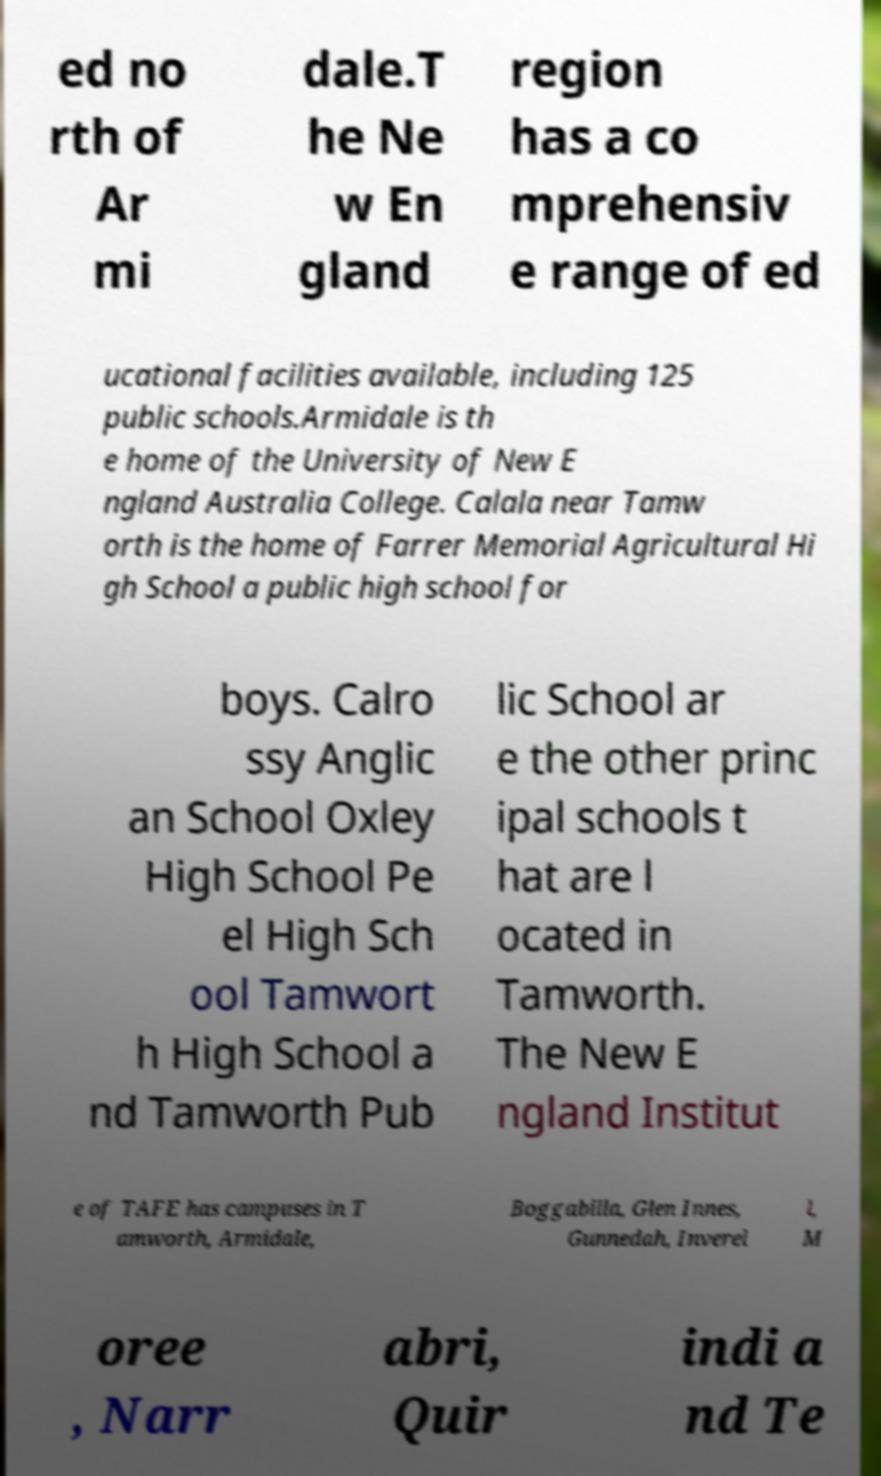For documentation purposes, I need the text within this image transcribed. Could you provide that? ed no rth of Ar mi dale.T he Ne w En gland region has a co mprehensiv e range of ed ucational facilities available, including 125 public schools.Armidale is th e home of the University of New E ngland Australia College. Calala near Tamw orth is the home of Farrer Memorial Agricultural Hi gh School a public high school for boys. Calro ssy Anglic an School Oxley High School Pe el High Sch ool Tamwort h High School a nd Tamworth Pub lic School ar e the other princ ipal schools t hat are l ocated in Tamworth. The New E ngland Institut e of TAFE has campuses in T amworth, Armidale, Boggabilla, Glen Innes, Gunnedah, Inverel l, M oree , Narr abri, Quir indi a nd Te 